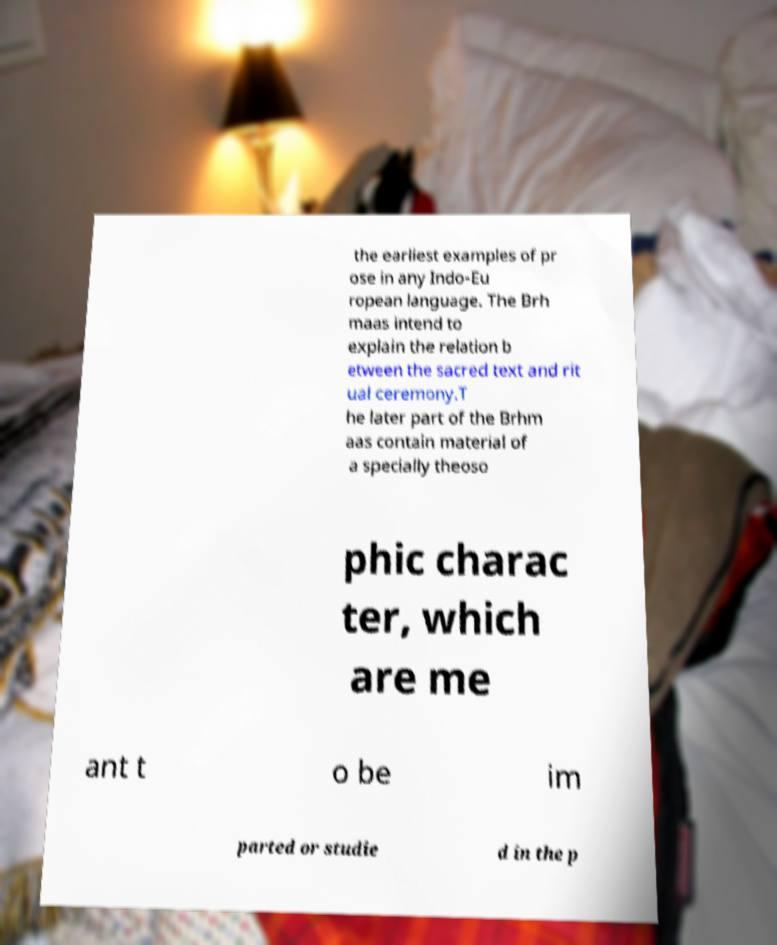Can you accurately transcribe the text from the provided image for me? the earliest examples of pr ose in any Indo-Eu ropean language. The Brh maas intend to explain the relation b etween the sacred text and rit ual ceremony.T he later part of the Brhm aas contain material of a specially theoso phic charac ter, which are me ant t o be im parted or studie d in the p 